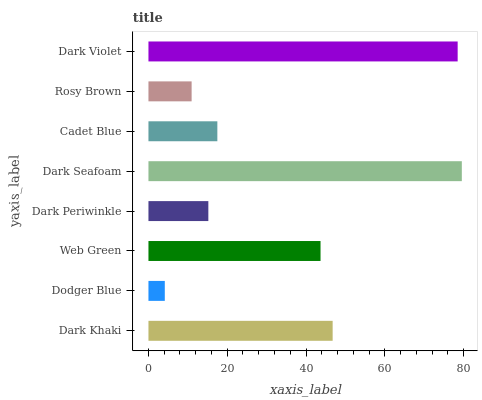Is Dodger Blue the minimum?
Answer yes or no. Yes. Is Dark Seafoam the maximum?
Answer yes or no. Yes. Is Web Green the minimum?
Answer yes or no. No. Is Web Green the maximum?
Answer yes or no. No. Is Web Green greater than Dodger Blue?
Answer yes or no. Yes. Is Dodger Blue less than Web Green?
Answer yes or no. Yes. Is Dodger Blue greater than Web Green?
Answer yes or no. No. Is Web Green less than Dodger Blue?
Answer yes or no. No. Is Web Green the high median?
Answer yes or no. Yes. Is Cadet Blue the low median?
Answer yes or no. Yes. Is Dark Khaki the high median?
Answer yes or no. No. Is Dark Seafoam the low median?
Answer yes or no. No. 